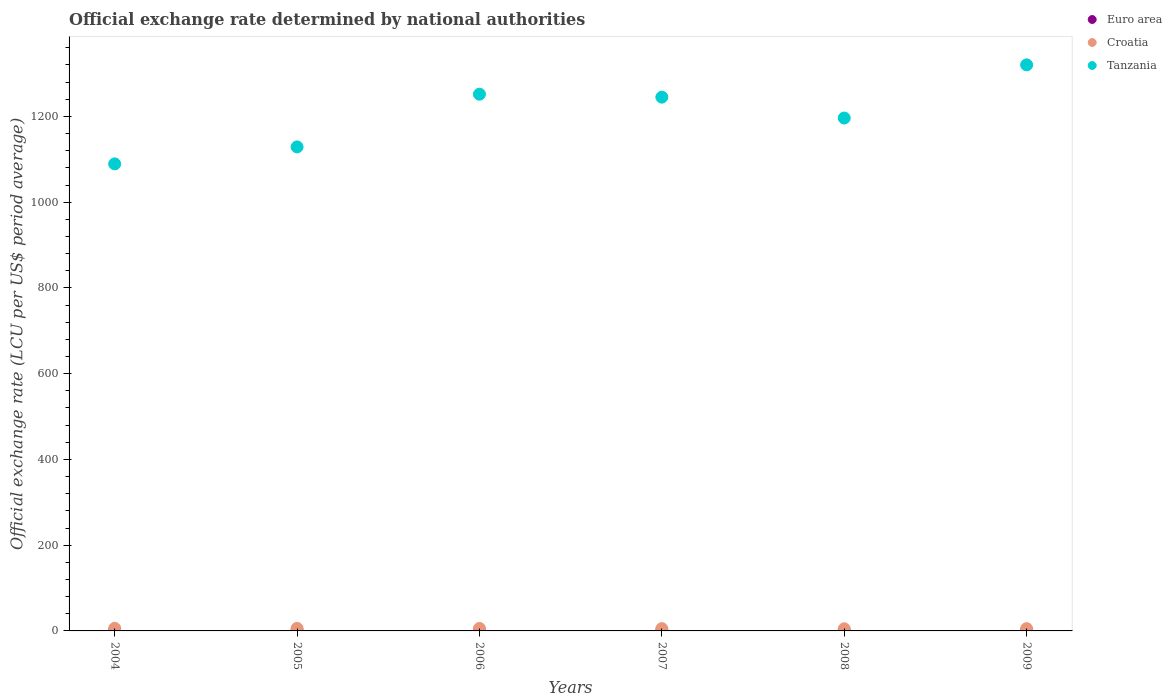How many different coloured dotlines are there?
Make the answer very short. 3. Is the number of dotlines equal to the number of legend labels?
Offer a very short reply. Yes. What is the official exchange rate in Tanzania in 2008?
Your response must be concise. 1196.31. Across all years, what is the maximum official exchange rate in Euro area?
Make the answer very short. 0.81. Across all years, what is the minimum official exchange rate in Croatia?
Make the answer very short. 4.94. In which year was the official exchange rate in Croatia maximum?
Offer a very short reply. 2004. In which year was the official exchange rate in Euro area minimum?
Make the answer very short. 2008. What is the total official exchange rate in Euro area in the graph?
Provide a succinct answer. 4.54. What is the difference between the official exchange rate in Tanzania in 2007 and that in 2008?
Keep it short and to the point. 48.72. What is the difference between the official exchange rate in Croatia in 2007 and the official exchange rate in Euro area in 2009?
Your answer should be compact. 4.64. What is the average official exchange rate in Euro area per year?
Offer a very short reply. 0.76. In the year 2008, what is the difference between the official exchange rate in Tanzania and official exchange rate in Croatia?
Your answer should be very brief. 1191.38. What is the ratio of the official exchange rate in Euro area in 2008 to that in 2009?
Offer a terse response. 0.95. Is the official exchange rate in Euro area in 2006 less than that in 2008?
Offer a terse response. No. What is the difference between the highest and the second highest official exchange rate in Croatia?
Make the answer very short. 0.09. What is the difference between the highest and the lowest official exchange rate in Tanzania?
Keep it short and to the point. 230.98. Is the sum of the official exchange rate in Tanzania in 2007 and 2008 greater than the maximum official exchange rate in Croatia across all years?
Ensure brevity in your answer.  Yes. Is it the case that in every year, the sum of the official exchange rate in Euro area and official exchange rate in Croatia  is greater than the official exchange rate in Tanzania?
Offer a very short reply. No. Does the official exchange rate in Euro area monotonically increase over the years?
Provide a short and direct response. No. Is the official exchange rate in Croatia strictly greater than the official exchange rate in Tanzania over the years?
Provide a short and direct response. No. How many dotlines are there?
Offer a terse response. 3. How many years are there in the graph?
Your answer should be very brief. 6. What is the difference between two consecutive major ticks on the Y-axis?
Provide a succinct answer. 200. Does the graph contain grids?
Keep it short and to the point. No. What is the title of the graph?
Ensure brevity in your answer.  Official exchange rate determined by national authorities. Does "Madagascar" appear as one of the legend labels in the graph?
Your response must be concise. No. What is the label or title of the X-axis?
Offer a terse response. Years. What is the label or title of the Y-axis?
Keep it short and to the point. Official exchange rate (LCU per US$ period average). What is the Official exchange rate (LCU per US$ period average) in Euro area in 2004?
Ensure brevity in your answer.  0.81. What is the Official exchange rate (LCU per US$ period average) in Croatia in 2004?
Offer a terse response. 6.03. What is the Official exchange rate (LCU per US$ period average) in Tanzania in 2004?
Offer a terse response. 1089.33. What is the Official exchange rate (LCU per US$ period average) in Euro area in 2005?
Make the answer very short. 0.8. What is the Official exchange rate (LCU per US$ period average) in Croatia in 2005?
Keep it short and to the point. 5.95. What is the Official exchange rate (LCU per US$ period average) in Tanzania in 2005?
Your answer should be compact. 1128.93. What is the Official exchange rate (LCU per US$ period average) in Euro area in 2006?
Make the answer very short. 0.8. What is the Official exchange rate (LCU per US$ period average) in Croatia in 2006?
Keep it short and to the point. 5.84. What is the Official exchange rate (LCU per US$ period average) in Tanzania in 2006?
Ensure brevity in your answer.  1251.9. What is the Official exchange rate (LCU per US$ period average) of Euro area in 2007?
Provide a short and direct response. 0.73. What is the Official exchange rate (LCU per US$ period average) of Croatia in 2007?
Ensure brevity in your answer.  5.36. What is the Official exchange rate (LCU per US$ period average) of Tanzania in 2007?
Offer a terse response. 1245.04. What is the Official exchange rate (LCU per US$ period average) in Euro area in 2008?
Provide a succinct answer. 0.68. What is the Official exchange rate (LCU per US$ period average) in Croatia in 2008?
Provide a short and direct response. 4.94. What is the Official exchange rate (LCU per US$ period average) in Tanzania in 2008?
Offer a very short reply. 1196.31. What is the Official exchange rate (LCU per US$ period average) of Euro area in 2009?
Give a very brief answer. 0.72. What is the Official exchange rate (LCU per US$ period average) of Croatia in 2009?
Offer a terse response. 5.28. What is the Official exchange rate (LCU per US$ period average) in Tanzania in 2009?
Your response must be concise. 1320.31. Across all years, what is the maximum Official exchange rate (LCU per US$ period average) in Euro area?
Provide a succinct answer. 0.81. Across all years, what is the maximum Official exchange rate (LCU per US$ period average) in Croatia?
Ensure brevity in your answer.  6.03. Across all years, what is the maximum Official exchange rate (LCU per US$ period average) in Tanzania?
Your response must be concise. 1320.31. Across all years, what is the minimum Official exchange rate (LCU per US$ period average) in Euro area?
Provide a short and direct response. 0.68. Across all years, what is the minimum Official exchange rate (LCU per US$ period average) of Croatia?
Your answer should be very brief. 4.94. Across all years, what is the minimum Official exchange rate (LCU per US$ period average) in Tanzania?
Ensure brevity in your answer.  1089.33. What is the total Official exchange rate (LCU per US$ period average) of Euro area in the graph?
Make the answer very short. 4.54. What is the total Official exchange rate (LCU per US$ period average) in Croatia in the graph?
Your answer should be very brief. 33.4. What is the total Official exchange rate (LCU per US$ period average) of Tanzania in the graph?
Provide a short and direct response. 7231.83. What is the difference between the Official exchange rate (LCU per US$ period average) of Euro area in 2004 and that in 2005?
Ensure brevity in your answer.  0. What is the difference between the Official exchange rate (LCU per US$ period average) in Croatia in 2004 and that in 2005?
Your response must be concise. 0.09. What is the difference between the Official exchange rate (LCU per US$ period average) in Tanzania in 2004 and that in 2005?
Offer a very short reply. -39.6. What is the difference between the Official exchange rate (LCU per US$ period average) in Euro area in 2004 and that in 2006?
Offer a terse response. 0.01. What is the difference between the Official exchange rate (LCU per US$ period average) of Croatia in 2004 and that in 2006?
Provide a short and direct response. 0.2. What is the difference between the Official exchange rate (LCU per US$ period average) in Tanzania in 2004 and that in 2006?
Your answer should be compact. -162.57. What is the difference between the Official exchange rate (LCU per US$ period average) of Euro area in 2004 and that in 2007?
Offer a terse response. 0.07. What is the difference between the Official exchange rate (LCU per US$ period average) of Croatia in 2004 and that in 2007?
Your response must be concise. 0.67. What is the difference between the Official exchange rate (LCU per US$ period average) of Tanzania in 2004 and that in 2007?
Keep it short and to the point. -155.7. What is the difference between the Official exchange rate (LCU per US$ period average) of Euro area in 2004 and that in 2008?
Your response must be concise. 0.12. What is the difference between the Official exchange rate (LCU per US$ period average) in Croatia in 2004 and that in 2008?
Give a very brief answer. 1.1. What is the difference between the Official exchange rate (LCU per US$ period average) of Tanzania in 2004 and that in 2008?
Keep it short and to the point. -106.98. What is the difference between the Official exchange rate (LCU per US$ period average) of Euro area in 2004 and that in 2009?
Ensure brevity in your answer.  0.09. What is the difference between the Official exchange rate (LCU per US$ period average) of Croatia in 2004 and that in 2009?
Keep it short and to the point. 0.75. What is the difference between the Official exchange rate (LCU per US$ period average) in Tanzania in 2004 and that in 2009?
Offer a terse response. -230.98. What is the difference between the Official exchange rate (LCU per US$ period average) of Euro area in 2005 and that in 2006?
Your answer should be very brief. 0.01. What is the difference between the Official exchange rate (LCU per US$ period average) of Croatia in 2005 and that in 2006?
Give a very brief answer. 0.11. What is the difference between the Official exchange rate (LCU per US$ period average) in Tanzania in 2005 and that in 2006?
Provide a succinct answer. -122.97. What is the difference between the Official exchange rate (LCU per US$ period average) of Euro area in 2005 and that in 2007?
Provide a short and direct response. 0.07. What is the difference between the Official exchange rate (LCU per US$ period average) in Croatia in 2005 and that in 2007?
Your answer should be compact. 0.58. What is the difference between the Official exchange rate (LCU per US$ period average) in Tanzania in 2005 and that in 2007?
Ensure brevity in your answer.  -116.1. What is the difference between the Official exchange rate (LCU per US$ period average) of Euro area in 2005 and that in 2008?
Your answer should be very brief. 0.12. What is the difference between the Official exchange rate (LCU per US$ period average) in Croatia in 2005 and that in 2008?
Your answer should be very brief. 1.01. What is the difference between the Official exchange rate (LCU per US$ period average) in Tanzania in 2005 and that in 2008?
Offer a very short reply. -67.38. What is the difference between the Official exchange rate (LCU per US$ period average) in Euro area in 2005 and that in 2009?
Your answer should be very brief. 0.08. What is the difference between the Official exchange rate (LCU per US$ period average) of Croatia in 2005 and that in 2009?
Give a very brief answer. 0.67. What is the difference between the Official exchange rate (LCU per US$ period average) of Tanzania in 2005 and that in 2009?
Your response must be concise. -191.38. What is the difference between the Official exchange rate (LCU per US$ period average) of Euro area in 2006 and that in 2007?
Provide a succinct answer. 0.07. What is the difference between the Official exchange rate (LCU per US$ period average) in Croatia in 2006 and that in 2007?
Provide a succinct answer. 0.47. What is the difference between the Official exchange rate (LCU per US$ period average) in Tanzania in 2006 and that in 2007?
Your answer should be very brief. 6.86. What is the difference between the Official exchange rate (LCU per US$ period average) of Euro area in 2006 and that in 2008?
Keep it short and to the point. 0.11. What is the difference between the Official exchange rate (LCU per US$ period average) in Croatia in 2006 and that in 2008?
Keep it short and to the point. 0.9. What is the difference between the Official exchange rate (LCU per US$ period average) of Tanzania in 2006 and that in 2008?
Provide a succinct answer. 55.59. What is the difference between the Official exchange rate (LCU per US$ period average) of Euro area in 2006 and that in 2009?
Keep it short and to the point. 0.08. What is the difference between the Official exchange rate (LCU per US$ period average) in Croatia in 2006 and that in 2009?
Keep it short and to the point. 0.55. What is the difference between the Official exchange rate (LCU per US$ period average) of Tanzania in 2006 and that in 2009?
Provide a short and direct response. -68.41. What is the difference between the Official exchange rate (LCU per US$ period average) of Euro area in 2007 and that in 2008?
Offer a very short reply. 0.05. What is the difference between the Official exchange rate (LCU per US$ period average) in Croatia in 2007 and that in 2008?
Ensure brevity in your answer.  0.43. What is the difference between the Official exchange rate (LCU per US$ period average) of Tanzania in 2007 and that in 2008?
Your answer should be compact. 48.72. What is the difference between the Official exchange rate (LCU per US$ period average) in Euro area in 2007 and that in 2009?
Keep it short and to the point. 0.01. What is the difference between the Official exchange rate (LCU per US$ period average) in Croatia in 2007 and that in 2009?
Make the answer very short. 0.08. What is the difference between the Official exchange rate (LCU per US$ period average) of Tanzania in 2007 and that in 2009?
Keep it short and to the point. -75.28. What is the difference between the Official exchange rate (LCU per US$ period average) in Euro area in 2008 and that in 2009?
Offer a terse response. -0.04. What is the difference between the Official exchange rate (LCU per US$ period average) in Croatia in 2008 and that in 2009?
Provide a succinct answer. -0.35. What is the difference between the Official exchange rate (LCU per US$ period average) in Tanzania in 2008 and that in 2009?
Give a very brief answer. -124. What is the difference between the Official exchange rate (LCU per US$ period average) of Euro area in 2004 and the Official exchange rate (LCU per US$ period average) of Croatia in 2005?
Provide a succinct answer. -5.14. What is the difference between the Official exchange rate (LCU per US$ period average) in Euro area in 2004 and the Official exchange rate (LCU per US$ period average) in Tanzania in 2005?
Offer a terse response. -1128.13. What is the difference between the Official exchange rate (LCU per US$ period average) in Croatia in 2004 and the Official exchange rate (LCU per US$ period average) in Tanzania in 2005?
Offer a very short reply. -1122.9. What is the difference between the Official exchange rate (LCU per US$ period average) in Euro area in 2004 and the Official exchange rate (LCU per US$ period average) in Croatia in 2006?
Ensure brevity in your answer.  -5.03. What is the difference between the Official exchange rate (LCU per US$ period average) in Euro area in 2004 and the Official exchange rate (LCU per US$ period average) in Tanzania in 2006?
Provide a short and direct response. -1251.09. What is the difference between the Official exchange rate (LCU per US$ period average) in Croatia in 2004 and the Official exchange rate (LCU per US$ period average) in Tanzania in 2006?
Give a very brief answer. -1245.87. What is the difference between the Official exchange rate (LCU per US$ period average) in Euro area in 2004 and the Official exchange rate (LCU per US$ period average) in Croatia in 2007?
Keep it short and to the point. -4.56. What is the difference between the Official exchange rate (LCU per US$ period average) in Euro area in 2004 and the Official exchange rate (LCU per US$ period average) in Tanzania in 2007?
Ensure brevity in your answer.  -1244.23. What is the difference between the Official exchange rate (LCU per US$ period average) in Croatia in 2004 and the Official exchange rate (LCU per US$ period average) in Tanzania in 2007?
Keep it short and to the point. -1239. What is the difference between the Official exchange rate (LCU per US$ period average) of Euro area in 2004 and the Official exchange rate (LCU per US$ period average) of Croatia in 2008?
Your answer should be very brief. -4.13. What is the difference between the Official exchange rate (LCU per US$ period average) of Euro area in 2004 and the Official exchange rate (LCU per US$ period average) of Tanzania in 2008?
Your answer should be very brief. -1195.51. What is the difference between the Official exchange rate (LCU per US$ period average) in Croatia in 2004 and the Official exchange rate (LCU per US$ period average) in Tanzania in 2008?
Ensure brevity in your answer.  -1190.28. What is the difference between the Official exchange rate (LCU per US$ period average) in Euro area in 2004 and the Official exchange rate (LCU per US$ period average) in Croatia in 2009?
Give a very brief answer. -4.48. What is the difference between the Official exchange rate (LCU per US$ period average) in Euro area in 2004 and the Official exchange rate (LCU per US$ period average) in Tanzania in 2009?
Offer a terse response. -1319.51. What is the difference between the Official exchange rate (LCU per US$ period average) of Croatia in 2004 and the Official exchange rate (LCU per US$ period average) of Tanzania in 2009?
Offer a very short reply. -1314.28. What is the difference between the Official exchange rate (LCU per US$ period average) of Euro area in 2005 and the Official exchange rate (LCU per US$ period average) of Croatia in 2006?
Offer a terse response. -5.03. What is the difference between the Official exchange rate (LCU per US$ period average) of Euro area in 2005 and the Official exchange rate (LCU per US$ period average) of Tanzania in 2006?
Give a very brief answer. -1251.1. What is the difference between the Official exchange rate (LCU per US$ period average) of Croatia in 2005 and the Official exchange rate (LCU per US$ period average) of Tanzania in 2006?
Give a very brief answer. -1245.95. What is the difference between the Official exchange rate (LCU per US$ period average) in Euro area in 2005 and the Official exchange rate (LCU per US$ period average) in Croatia in 2007?
Offer a very short reply. -4.56. What is the difference between the Official exchange rate (LCU per US$ period average) in Euro area in 2005 and the Official exchange rate (LCU per US$ period average) in Tanzania in 2007?
Keep it short and to the point. -1244.23. What is the difference between the Official exchange rate (LCU per US$ period average) in Croatia in 2005 and the Official exchange rate (LCU per US$ period average) in Tanzania in 2007?
Make the answer very short. -1239.09. What is the difference between the Official exchange rate (LCU per US$ period average) of Euro area in 2005 and the Official exchange rate (LCU per US$ period average) of Croatia in 2008?
Provide a succinct answer. -4.13. What is the difference between the Official exchange rate (LCU per US$ period average) in Euro area in 2005 and the Official exchange rate (LCU per US$ period average) in Tanzania in 2008?
Your response must be concise. -1195.51. What is the difference between the Official exchange rate (LCU per US$ period average) of Croatia in 2005 and the Official exchange rate (LCU per US$ period average) of Tanzania in 2008?
Keep it short and to the point. -1190.36. What is the difference between the Official exchange rate (LCU per US$ period average) of Euro area in 2005 and the Official exchange rate (LCU per US$ period average) of Croatia in 2009?
Provide a succinct answer. -4.48. What is the difference between the Official exchange rate (LCU per US$ period average) in Euro area in 2005 and the Official exchange rate (LCU per US$ period average) in Tanzania in 2009?
Ensure brevity in your answer.  -1319.51. What is the difference between the Official exchange rate (LCU per US$ period average) in Croatia in 2005 and the Official exchange rate (LCU per US$ period average) in Tanzania in 2009?
Your answer should be compact. -1314.36. What is the difference between the Official exchange rate (LCU per US$ period average) of Euro area in 2006 and the Official exchange rate (LCU per US$ period average) of Croatia in 2007?
Your answer should be compact. -4.57. What is the difference between the Official exchange rate (LCU per US$ period average) in Euro area in 2006 and the Official exchange rate (LCU per US$ period average) in Tanzania in 2007?
Offer a terse response. -1244.24. What is the difference between the Official exchange rate (LCU per US$ period average) in Croatia in 2006 and the Official exchange rate (LCU per US$ period average) in Tanzania in 2007?
Ensure brevity in your answer.  -1239.2. What is the difference between the Official exchange rate (LCU per US$ period average) of Euro area in 2006 and the Official exchange rate (LCU per US$ period average) of Croatia in 2008?
Offer a terse response. -4.14. What is the difference between the Official exchange rate (LCU per US$ period average) in Euro area in 2006 and the Official exchange rate (LCU per US$ period average) in Tanzania in 2008?
Keep it short and to the point. -1195.51. What is the difference between the Official exchange rate (LCU per US$ period average) of Croatia in 2006 and the Official exchange rate (LCU per US$ period average) of Tanzania in 2008?
Your answer should be compact. -1190.47. What is the difference between the Official exchange rate (LCU per US$ period average) in Euro area in 2006 and the Official exchange rate (LCU per US$ period average) in Croatia in 2009?
Offer a very short reply. -4.49. What is the difference between the Official exchange rate (LCU per US$ period average) of Euro area in 2006 and the Official exchange rate (LCU per US$ period average) of Tanzania in 2009?
Ensure brevity in your answer.  -1319.51. What is the difference between the Official exchange rate (LCU per US$ period average) of Croatia in 2006 and the Official exchange rate (LCU per US$ period average) of Tanzania in 2009?
Offer a very short reply. -1314.47. What is the difference between the Official exchange rate (LCU per US$ period average) in Euro area in 2007 and the Official exchange rate (LCU per US$ period average) in Croatia in 2008?
Provide a short and direct response. -4.2. What is the difference between the Official exchange rate (LCU per US$ period average) in Euro area in 2007 and the Official exchange rate (LCU per US$ period average) in Tanzania in 2008?
Provide a succinct answer. -1195.58. What is the difference between the Official exchange rate (LCU per US$ period average) in Croatia in 2007 and the Official exchange rate (LCU per US$ period average) in Tanzania in 2008?
Make the answer very short. -1190.95. What is the difference between the Official exchange rate (LCU per US$ period average) in Euro area in 2007 and the Official exchange rate (LCU per US$ period average) in Croatia in 2009?
Offer a terse response. -4.55. What is the difference between the Official exchange rate (LCU per US$ period average) of Euro area in 2007 and the Official exchange rate (LCU per US$ period average) of Tanzania in 2009?
Offer a very short reply. -1319.58. What is the difference between the Official exchange rate (LCU per US$ period average) in Croatia in 2007 and the Official exchange rate (LCU per US$ period average) in Tanzania in 2009?
Your answer should be compact. -1314.95. What is the difference between the Official exchange rate (LCU per US$ period average) of Euro area in 2008 and the Official exchange rate (LCU per US$ period average) of Croatia in 2009?
Provide a succinct answer. -4.6. What is the difference between the Official exchange rate (LCU per US$ period average) in Euro area in 2008 and the Official exchange rate (LCU per US$ period average) in Tanzania in 2009?
Your answer should be very brief. -1319.63. What is the difference between the Official exchange rate (LCU per US$ period average) in Croatia in 2008 and the Official exchange rate (LCU per US$ period average) in Tanzania in 2009?
Give a very brief answer. -1315.38. What is the average Official exchange rate (LCU per US$ period average) of Euro area per year?
Ensure brevity in your answer.  0.76. What is the average Official exchange rate (LCU per US$ period average) of Croatia per year?
Provide a succinct answer. 5.57. What is the average Official exchange rate (LCU per US$ period average) in Tanzania per year?
Your answer should be very brief. 1205.3. In the year 2004, what is the difference between the Official exchange rate (LCU per US$ period average) in Euro area and Official exchange rate (LCU per US$ period average) in Croatia?
Make the answer very short. -5.23. In the year 2004, what is the difference between the Official exchange rate (LCU per US$ period average) in Euro area and Official exchange rate (LCU per US$ period average) in Tanzania?
Ensure brevity in your answer.  -1088.53. In the year 2004, what is the difference between the Official exchange rate (LCU per US$ period average) in Croatia and Official exchange rate (LCU per US$ period average) in Tanzania?
Keep it short and to the point. -1083.3. In the year 2005, what is the difference between the Official exchange rate (LCU per US$ period average) in Euro area and Official exchange rate (LCU per US$ period average) in Croatia?
Keep it short and to the point. -5.15. In the year 2005, what is the difference between the Official exchange rate (LCU per US$ period average) of Euro area and Official exchange rate (LCU per US$ period average) of Tanzania?
Provide a short and direct response. -1128.13. In the year 2005, what is the difference between the Official exchange rate (LCU per US$ period average) in Croatia and Official exchange rate (LCU per US$ period average) in Tanzania?
Your answer should be compact. -1122.98. In the year 2006, what is the difference between the Official exchange rate (LCU per US$ period average) in Euro area and Official exchange rate (LCU per US$ period average) in Croatia?
Your response must be concise. -5.04. In the year 2006, what is the difference between the Official exchange rate (LCU per US$ period average) in Euro area and Official exchange rate (LCU per US$ period average) in Tanzania?
Keep it short and to the point. -1251.1. In the year 2006, what is the difference between the Official exchange rate (LCU per US$ period average) in Croatia and Official exchange rate (LCU per US$ period average) in Tanzania?
Ensure brevity in your answer.  -1246.06. In the year 2007, what is the difference between the Official exchange rate (LCU per US$ period average) in Euro area and Official exchange rate (LCU per US$ period average) in Croatia?
Provide a short and direct response. -4.63. In the year 2007, what is the difference between the Official exchange rate (LCU per US$ period average) in Euro area and Official exchange rate (LCU per US$ period average) in Tanzania?
Ensure brevity in your answer.  -1244.3. In the year 2007, what is the difference between the Official exchange rate (LCU per US$ period average) in Croatia and Official exchange rate (LCU per US$ period average) in Tanzania?
Offer a terse response. -1239.67. In the year 2008, what is the difference between the Official exchange rate (LCU per US$ period average) of Euro area and Official exchange rate (LCU per US$ period average) of Croatia?
Provide a short and direct response. -4.25. In the year 2008, what is the difference between the Official exchange rate (LCU per US$ period average) in Euro area and Official exchange rate (LCU per US$ period average) in Tanzania?
Offer a terse response. -1195.63. In the year 2008, what is the difference between the Official exchange rate (LCU per US$ period average) of Croatia and Official exchange rate (LCU per US$ period average) of Tanzania?
Offer a terse response. -1191.38. In the year 2009, what is the difference between the Official exchange rate (LCU per US$ period average) in Euro area and Official exchange rate (LCU per US$ period average) in Croatia?
Keep it short and to the point. -4.56. In the year 2009, what is the difference between the Official exchange rate (LCU per US$ period average) of Euro area and Official exchange rate (LCU per US$ period average) of Tanzania?
Make the answer very short. -1319.59. In the year 2009, what is the difference between the Official exchange rate (LCU per US$ period average) of Croatia and Official exchange rate (LCU per US$ period average) of Tanzania?
Offer a terse response. -1315.03. What is the ratio of the Official exchange rate (LCU per US$ period average) of Euro area in 2004 to that in 2005?
Your answer should be compact. 1. What is the ratio of the Official exchange rate (LCU per US$ period average) in Croatia in 2004 to that in 2005?
Make the answer very short. 1.01. What is the ratio of the Official exchange rate (LCU per US$ period average) of Tanzania in 2004 to that in 2005?
Provide a succinct answer. 0.96. What is the ratio of the Official exchange rate (LCU per US$ period average) of Euro area in 2004 to that in 2006?
Your answer should be compact. 1.01. What is the ratio of the Official exchange rate (LCU per US$ period average) in Croatia in 2004 to that in 2006?
Your response must be concise. 1.03. What is the ratio of the Official exchange rate (LCU per US$ period average) of Tanzania in 2004 to that in 2006?
Your response must be concise. 0.87. What is the ratio of the Official exchange rate (LCU per US$ period average) in Euro area in 2004 to that in 2007?
Your response must be concise. 1.1. What is the ratio of the Official exchange rate (LCU per US$ period average) in Croatia in 2004 to that in 2007?
Offer a very short reply. 1.12. What is the ratio of the Official exchange rate (LCU per US$ period average) of Tanzania in 2004 to that in 2007?
Ensure brevity in your answer.  0.87. What is the ratio of the Official exchange rate (LCU per US$ period average) in Euro area in 2004 to that in 2008?
Offer a very short reply. 1.18. What is the ratio of the Official exchange rate (LCU per US$ period average) in Croatia in 2004 to that in 2008?
Keep it short and to the point. 1.22. What is the ratio of the Official exchange rate (LCU per US$ period average) of Tanzania in 2004 to that in 2008?
Offer a very short reply. 0.91. What is the ratio of the Official exchange rate (LCU per US$ period average) in Euro area in 2004 to that in 2009?
Provide a short and direct response. 1.12. What is the ratio of the Official exchange rate (LCU per US$ period average) in Croatia in 2004 to that in 2009?
Your answer should be compact. 1.14. What is the ratio of the Official exchange rate (LCU per US$ period average) of Tanzania in 2004 to that in 2009?
Provide a short and direct response. 0.83. What is the ratio of the Official exchange rate (LCU per US$ period average) in Euro area in 2005 to that in 2006?
Ensure brevity in your answer.  1.01. What is the ratio of the Official exchange rate (LCU per US$ period average) of Croatia in 2005 to that in 2006?
Your answer should be compact. 1.02. What is the ratio of the Official exchange rate (LCU per US$ period average) of Tanzania in 2005 to that in 2006?
Make the answer very short. 0.9. What is the ratio of the Official exchange rate (LCU per US$ period average) in Euro area in 2005 to that in 2007?
Offer a very short reply. 1.1. What is the ratio of the Official exchange rate (LCU per US$ period average) of Croatia in 2005 to that in 2007?
Make the answer very short. 1.11. What is the ratio of the Official exchange rate (LCU per US$ period average) in Tanzania in 2005 to that in 2007?
Provide a short and direct response. 0.91. What is the ratio of the Official exchange rate (LCU per US$ period average) of Euro area in 2005 to that in 2008?
Your response must be concise. 1.18. What is the ratio of the Official exchange rate (LCU per US$ period average) in Croatia in 2005 to that in 2008?
Your answer should be very brief. 1.21. What is the ratio of the Official exchange rate (LCU per US$ period average) of Tanzania in 2005 to that in 2008?
Ensure brevity in your answer.  0.94. What is the ratio of the Official exchange rate (LCU per US$ period average) in Euro area in 2005 to that in 2009?
Your answer should be compact. 1.12. What is the ratio of the Official exchange rate (LCU per US$ period average) in Croatia in 2005 to that in 2009?
Keep it short and to the point. 1.13. What is the ratio of the Official exchange rate (LCU per US$ period average) of Tanzania in 2005 to that in 2009?
Offer a terse response. 0.86. What is the ratio of the Official exchange rate (LCU per US$ period average) in Euro area in 2006 to that in 2007?
Make the answer very short. 1.09. What is the ratio of the Official exchange rate (LCU per US$ period average) in Croatia in 2006 to that in 2007?
Offer a terse response. 1.09. What is the ratio of the Official exchange rate (LCU per US$ period average) of Euro area in 2006 to that in 2008?
Keep it short and to the point. 1.17. What is the ratio of the Official exchange rate (LCU per US$ period average) in Croatia in 2006 to that in 2008?
Offer a very short reply. 1.18. What is the ratio of the Official exchange rate (LCU per US$ period average) of Tanzania in 2006 to that in 2008?
Make the answer very short. 1.05. What is the ratio of the Official exchange rate (LCU per US$ period average) of Euro area in 2006 to that in 2009?
Provide a succinct answer. 1.11. What is the ratio of the Official exchange rate (LCU per US$ period average) of Croatia in 2006 to that in 2009?
Give a very brief answer. 1.1. What is the ratio of the Official exchange rate (LCU per US$ period average) of Tanzania in 2006 to that in 2009?
Offer a terse response. 0.95. What is the ratio of the Official exchange rate (LCU per US$ period average) of Euro area in 2007 to that in 2008?
Your answer should be very brief. 1.07. What is the ratio of the Official exchange rate (LCU per US$ period average) in Croatia in 2007 to that in 2008?
Provide a succinct answer. 1.09. What is the ratio of the Official exchange rate (LCU per US$ period average) of Tanzania in 2007 to that in 2008?
Provide a succinct answer. 1.04. What is the ratio of the Official exchange rate (LCU per US$ period average) of Croatia in 2007 to that in 2009?
Keep it short and to the point. 1.02. What is the ratio of the Official exchange rate (LCU per US$ period average) in Tanzania in 2007 to that in 2009?
Your answer should be compact. 0.94. What is the ratio of the Official exchange rate (LCU per US$ period average) of Euro area in 2008 to that in 2009?
Your answer should be very brief. 0.95. What is the ratio of the Official exchange rate (LCU per US$ period average) in Croatia in 2008 to that in 2009?
Provide a succinct answer. 0.93. What is the ratio of the Official exchange rate (LCU per US$ period average) in Tanzania in 2008 to that in 2009?
Your answer should be compact. 0.91. What is the difference between the highest and the second highest Official exchange rate (LCU per US$ period average) of Euro area?
Provide a succinct answer. 0. What is the difference between the highest and the second highest Official exchange rate (LCU per US$ period average) in Croatia?
Your response must be concise. 0.09. What is the difference between the highest and the second highest Official exchange rate (LCU per US$ period average) of Tanzania?
Your response must be concise. 68.41. What is the difference between the highest and the lowest Official exchange rate (LCU per US$ period average) in Euro area?
Your answer should be very brief. 0.12. What is the difference between the highest and the lowest Official exchange rate (LCU per US$ period average) in Croatia?
Keep it short and to the point. 1.1. What is the difference between the highest and the lowest Official exchange rate (LCU per US$ period average) in Tanzania?
Give a very brief answer. 230.98. 